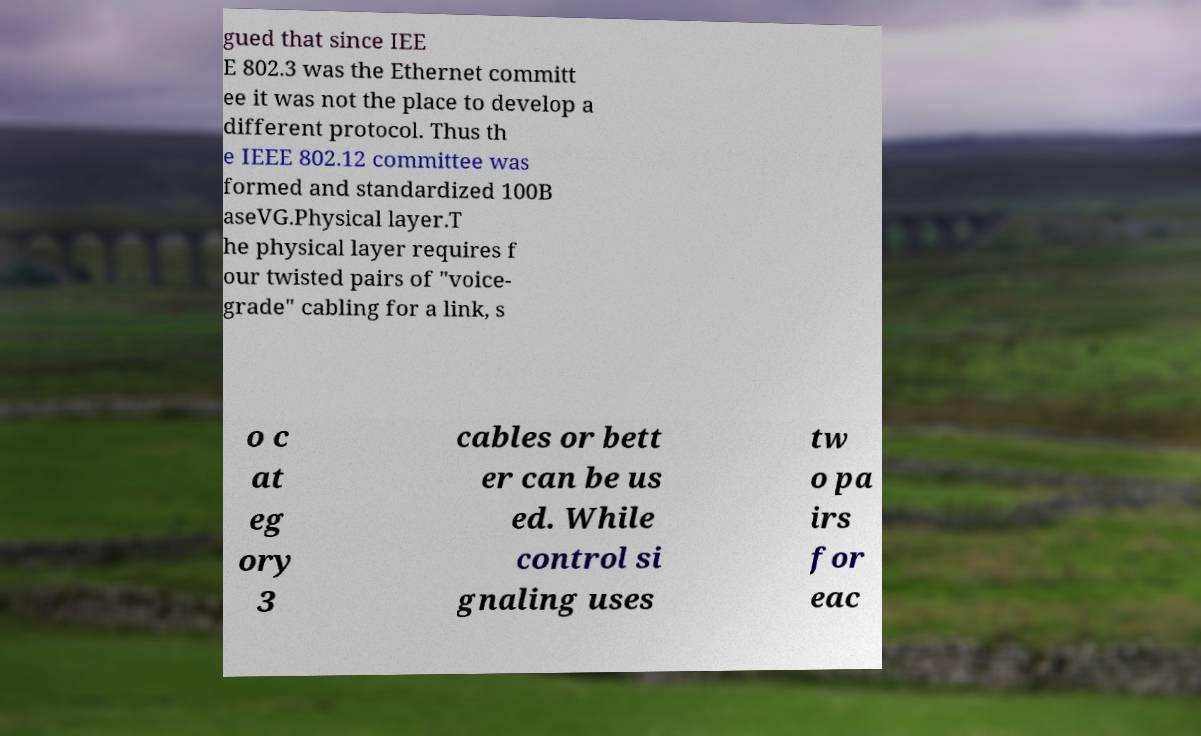Can you read and provide the text displayed in the image?This photo seems to have some interesting text. Can you extract and type it out for me? gued that since IEE E 802.3 was the Ethernet committ ee it was not the place to develop a different protocol. Thus th e IEEE 802.12 committee was formed and standardized 100B aseVG.Physical layer.T he physical layer requires f our twisted pairs of "voice- grade" cabling for a link, s o c at eg ory 3 cables or bett er can be us ed. While control si gnaling uses tw o pa irs for eac 